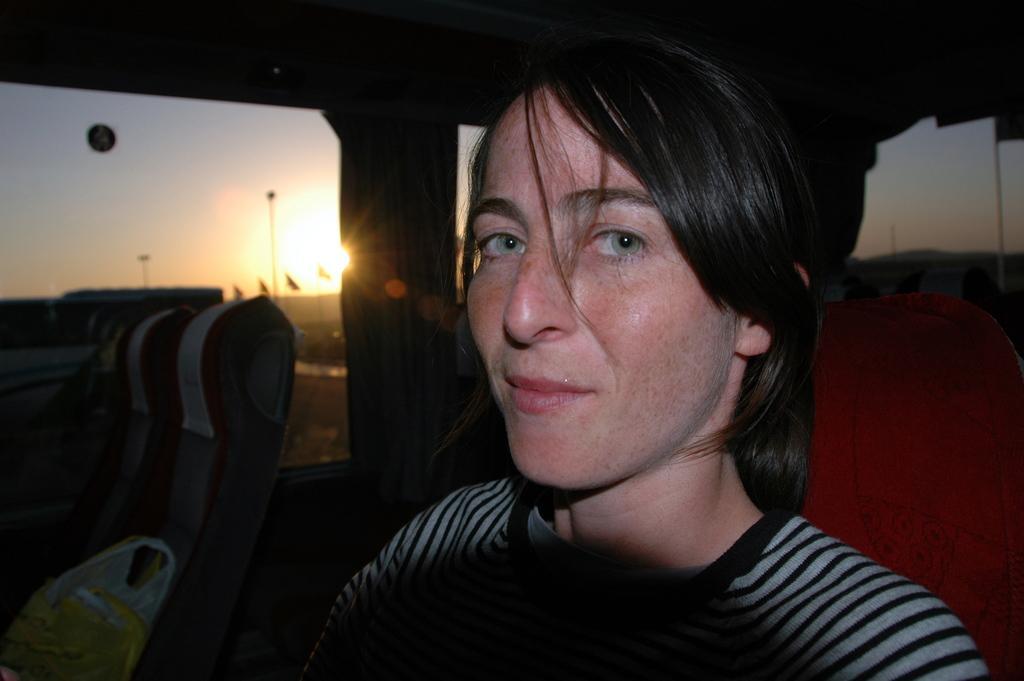In one or two sentences, can you explain what this image depicts? In this picture I can see there is a woman sitting and smiling, there is a window here and the sun and sky is visible from the window. 